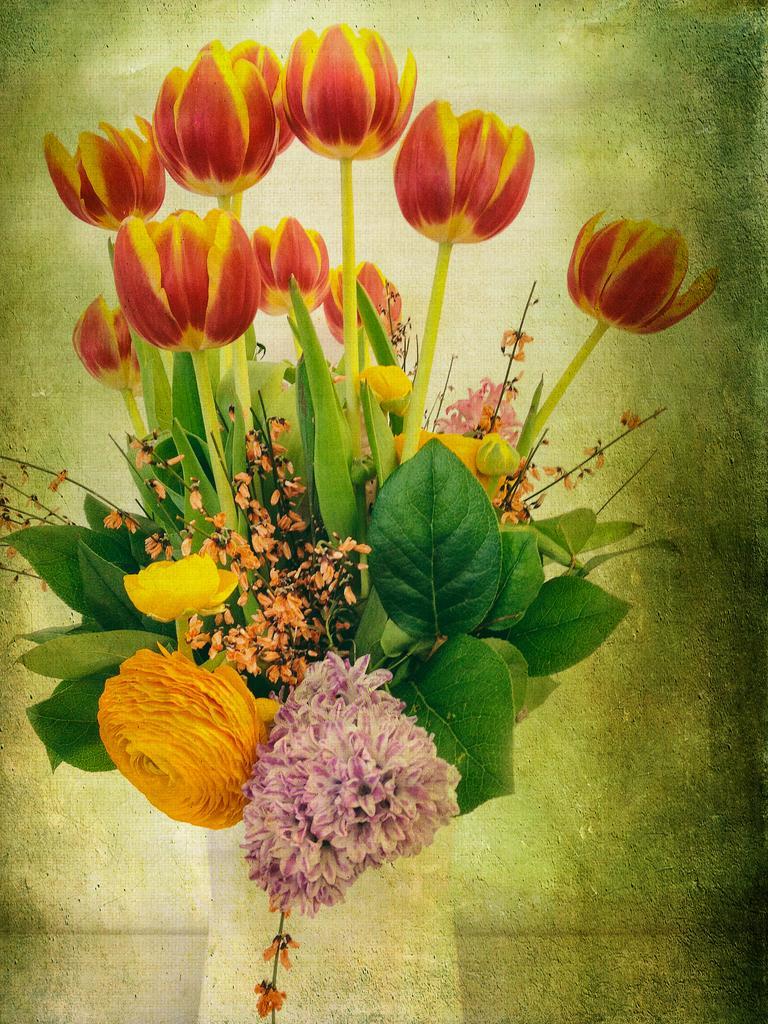Could you give a brief overview of what you see in this image? In the image there is a painting of flower vase with many flowers and leaves. And there is a green color background. 